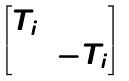<formula> <loc_0><loc_0><loc_500><loc_500>\begin{bmatrix} T _ { i } & \\ & - T _ { i } \end{bmatrix}</formula> 